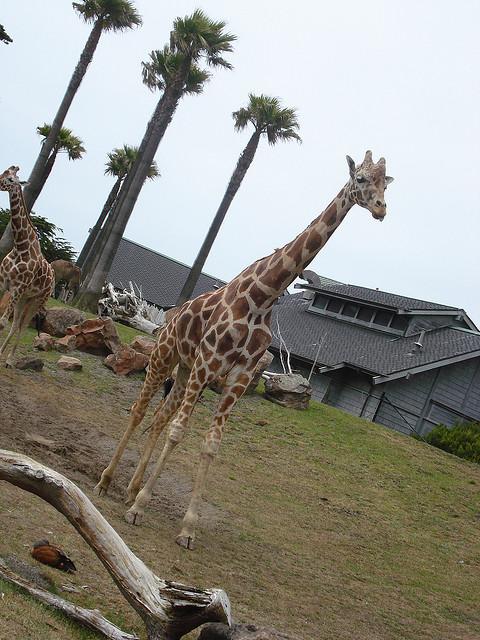Where is the shrubbery?
Short answer required. By building. How many windows are in the top of the building?
Short answer required. 6. What kind of trees are in the background?
Answer briefly. Palm. 